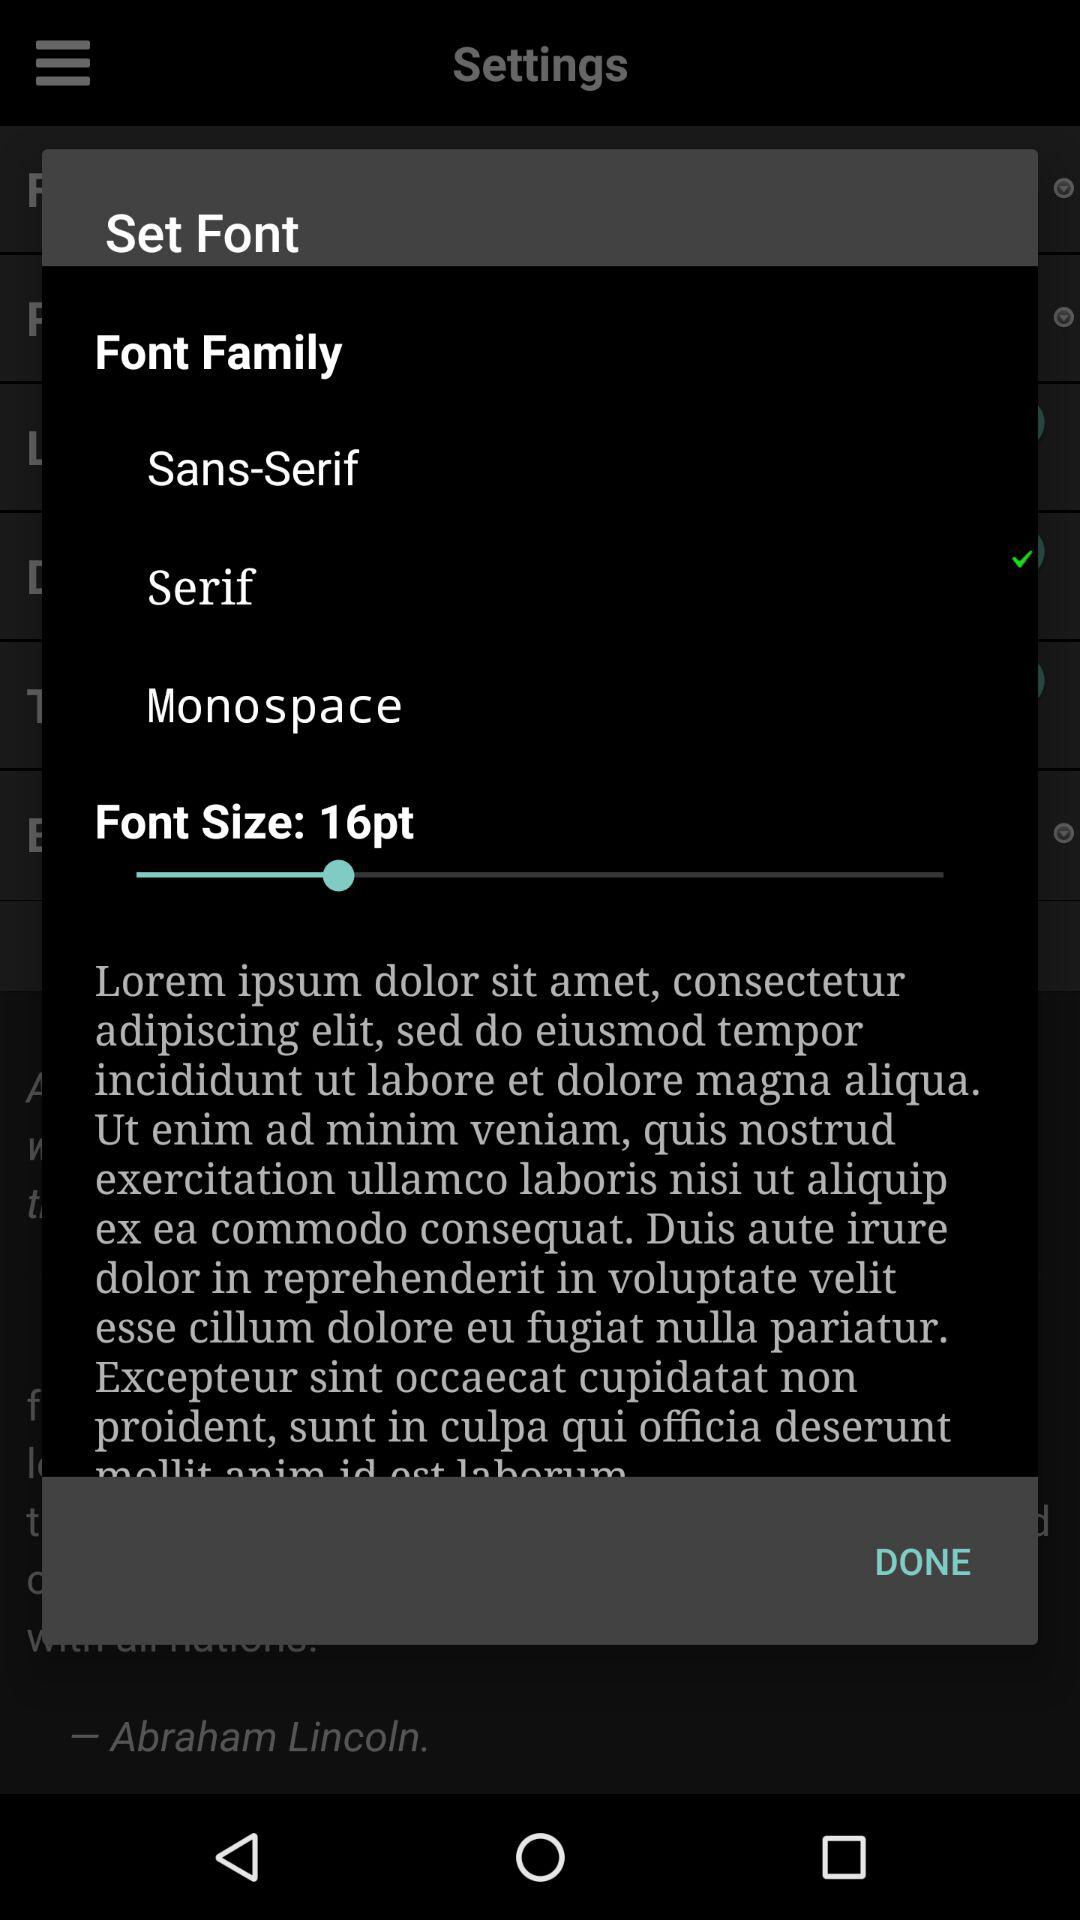How many font families are available?
Answer the question using a single word or phrase. 3 